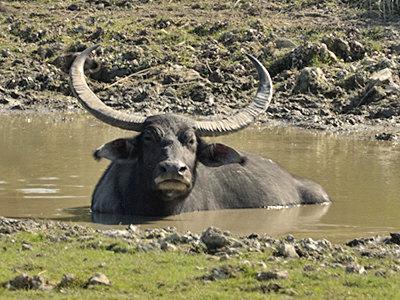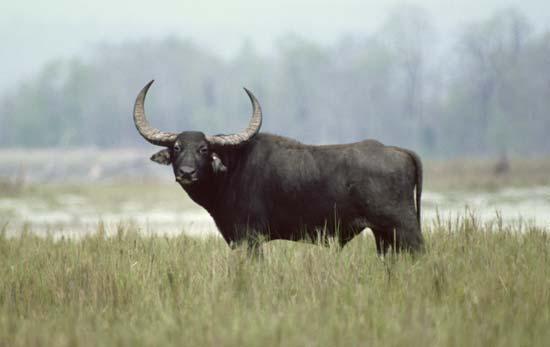The first image is the image on the left, the second image is the image on the right. Given the left and right images, does the statement "In one image, a water buffalo is submerged in water with its head and upper body showing." hold true? Answer yes or no. Yes. The first image is the image on the left, the second image is the image on the right. For the images displayed, is the sentence "An image shows exactly one water buffalo at least waist deep in water." factually correct? Answer yes or no. Yes. 